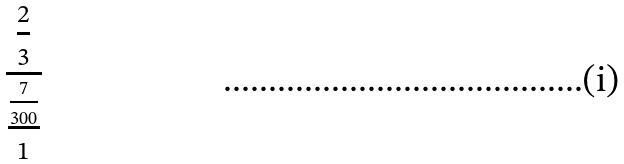Convert formula to latex. <formula><loc_0><loc_0><loc_500><loc_500>\frac { \frac { 2 } { 3 } } { \frac { \frac { 7 } { 3 0 0 } } { 1 } }</formula> 